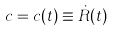<formula> <loc_0><loc_0><loc_500><loc_500>c = c ( t ) \equiv \dot { R } ( t )</formula> 